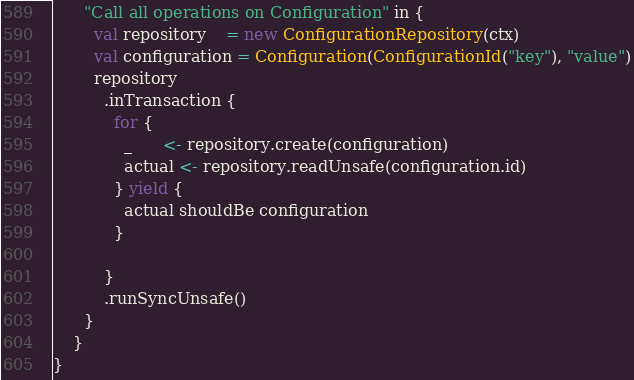<code> <loc_0><loc_0><loc_500><loc_500><_Scala_>      "Call all operations on Configuration" in {
        val repository    = new ConfigurationRepository(ctx)
        val configuration = Configuration(ConfigurationId("key"), "value")
        repository
          .inTransaction {
            for {
              _      <- repository.create(configuration)
              actual <- repository.readUnsafe(configuration.id)
            } yield {
              actual shouldBe configuration
            }

          }
          .runSyncUnsafe()
      }
    }
}
</code> 